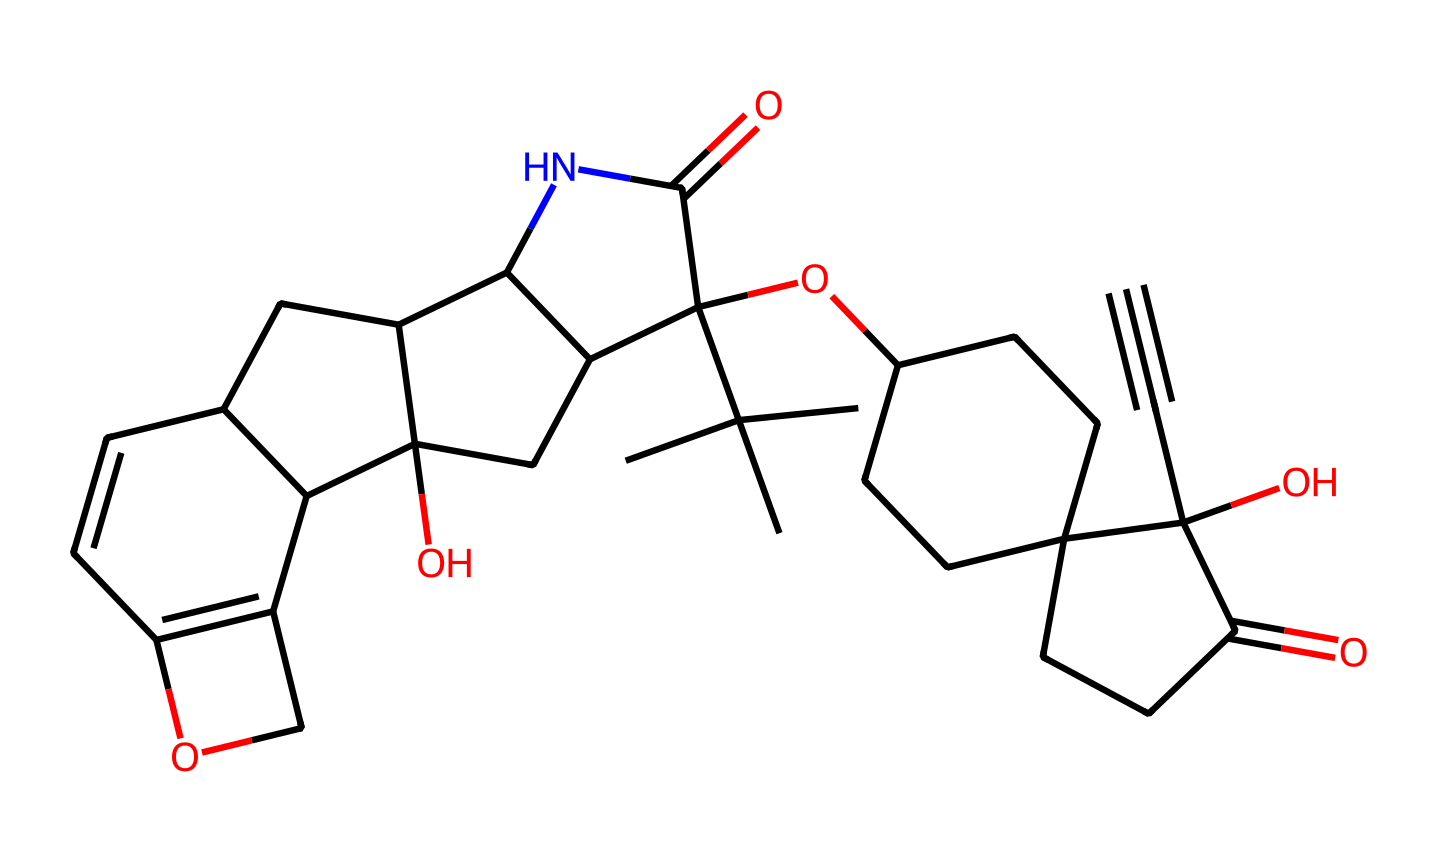What is the molecular formula of buprenorphine? To determine the molecular formula, count the number of each type of atom in the SMILES representation. The different types of atoms present in the chemical can be identified, leading to a count of 25 Carbons (C), 34 Hydrogens (H), 5 Nitrogens (N), and 3 Oxygens (O). The resulting molecular formula is C25H34N4O4.
Answer: C25H34N4O4 How many nitrogen atoms are in the chemical structure? By interpreting the SMILES, look for occurrences of nitrogen (N). The representation shows 4 Nitrogen atoms, which can be confirmed by simply counting the 'N' characters within the SMILES.
Answer: 4 What functional groups are present in buprenorphine? Identify common functional groups in the structure, including carbonyl (C=O), hydroxyl (OH), and amine (NH). The presence of these specific bonding arrangements indicates the functional groups that exist in buprenorphine. The determined functional groups are amide, alcohol, and ether.
Answer: amide, alcohol, ether What is the significance of the cyclic structure in buprenorphine? The presence of cyclic structures in the molecule contributes to its pharmacological properties by providing a stable conformation that interacts more effectively with opioid receptors. Cyclic systems often enhance receptor binding affinity and biological activity by maintaining a particular spatial arrangement essential for activity.
Answer: increases binding affinity How many chiral centers are present in buprenorphine? Count the chiral centers in the structure, which are usually carbon atoms bonded to four different substituents. By analyzing the stereochemistry through the visual representation of the SMILES, it can be concluded that there are 4 chiral centers in buprenorphine.
Answer: 4 What type of interaction is critical for buprenorphine's therapeutic effect? Recognize that opioids like buprenorphine function primarily through agonist-antagonist properties, interacting with mu-opioid receptors. These interactions are essential for its effectiveness in treating opioid dependence. This is mainly due to its partial agonist function, allowing it to produce effects similar to other opioids while reducing withdrawal symptoms.
Answer: receptor interaction 